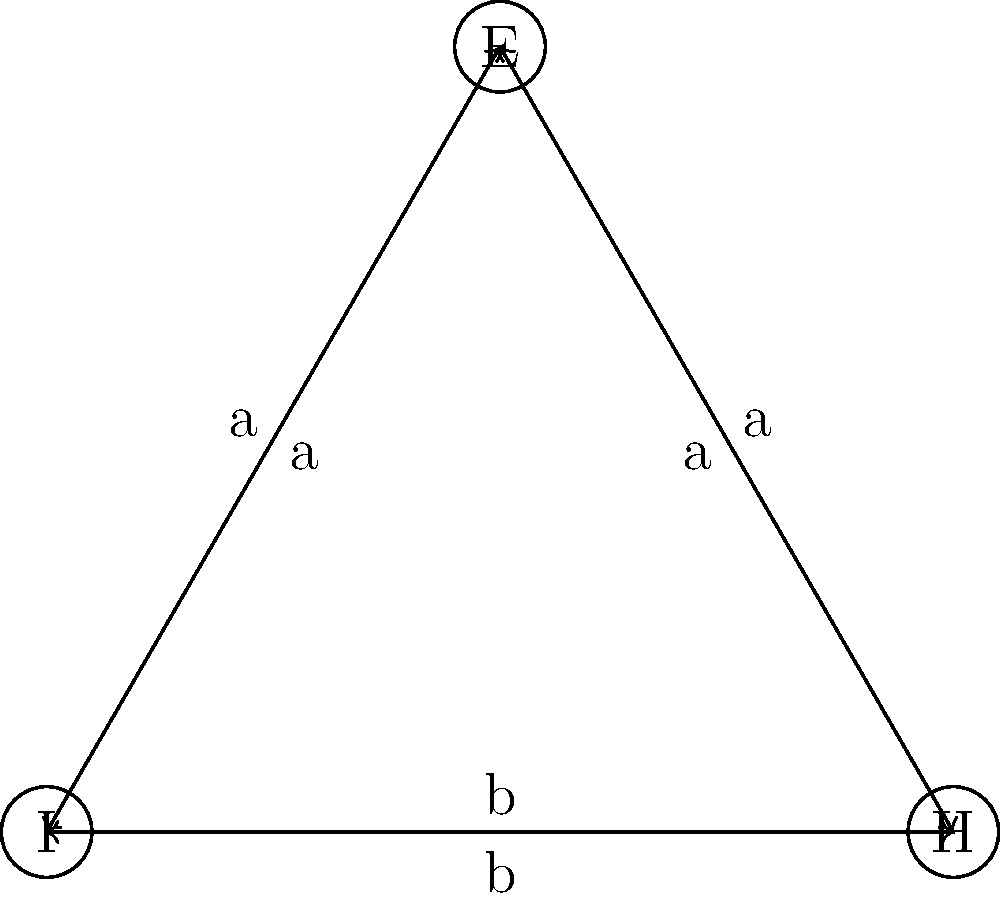Consider the Cayley diagram representing a stress-reducing breathing pattern, where 'I' represents the initial state, 'H' represents hold, and 'E' represents exhale. The generator 'a' represents a transition to exhale, and 'b' represents a transition to hold. What is the order of the group represented by this Cayley diagram? To determine the order of the group represented by this Cayley diagram, we need to follow these steps:

1. Identify the elements of the group:
   The vertices of the Cayley diagram represent the elements of the group. In this case, we have three elements: I (Initial state), H (Hold), and E (Exhale).

2. Verify the group properties:
   a) Closure: The diagram shows that applying generators 'a' and 'b' always leads to one of the three states, satisfying closure.
   b) Associativity: This is inherent in the structure of the Cayley diagram.
   c) Identity: The initial state 'I' serves as the identity element.
   d) Inverse: Each arrow has a corresponding arrow in the opposite direction, indicating that each operation has an inverse.

3. Count the number of elements:
   The group has 3 distinct elements: I, H, and E.

4. Conclude:
   The order of a group is defined as the number of elements in the group. In this case, we have 3 elements.

Therefore, the order of the group represented by this Cayley diagram is 3.
Answer: 3 